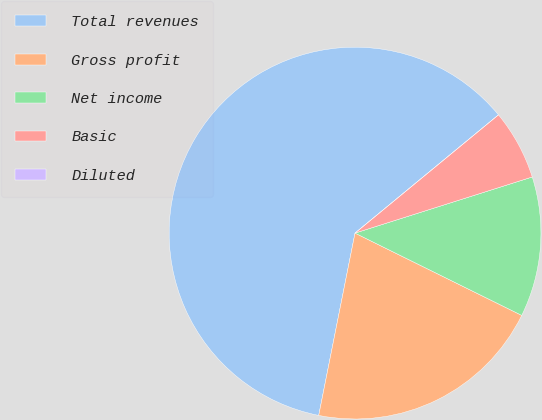Convert chart to OTSL. <chart><loc_0><loc_0><loc_500><loc_500><pie_chart><fcel>Total revenues<fcel>Gross profit<fcel>Net income<fcel>Basic<fcel>Diluted<nl><fcel>60.9%<fcel>20.83%<fcel>12.18%<fcel>6.09%<fcel>0.0%<nl></chart> 